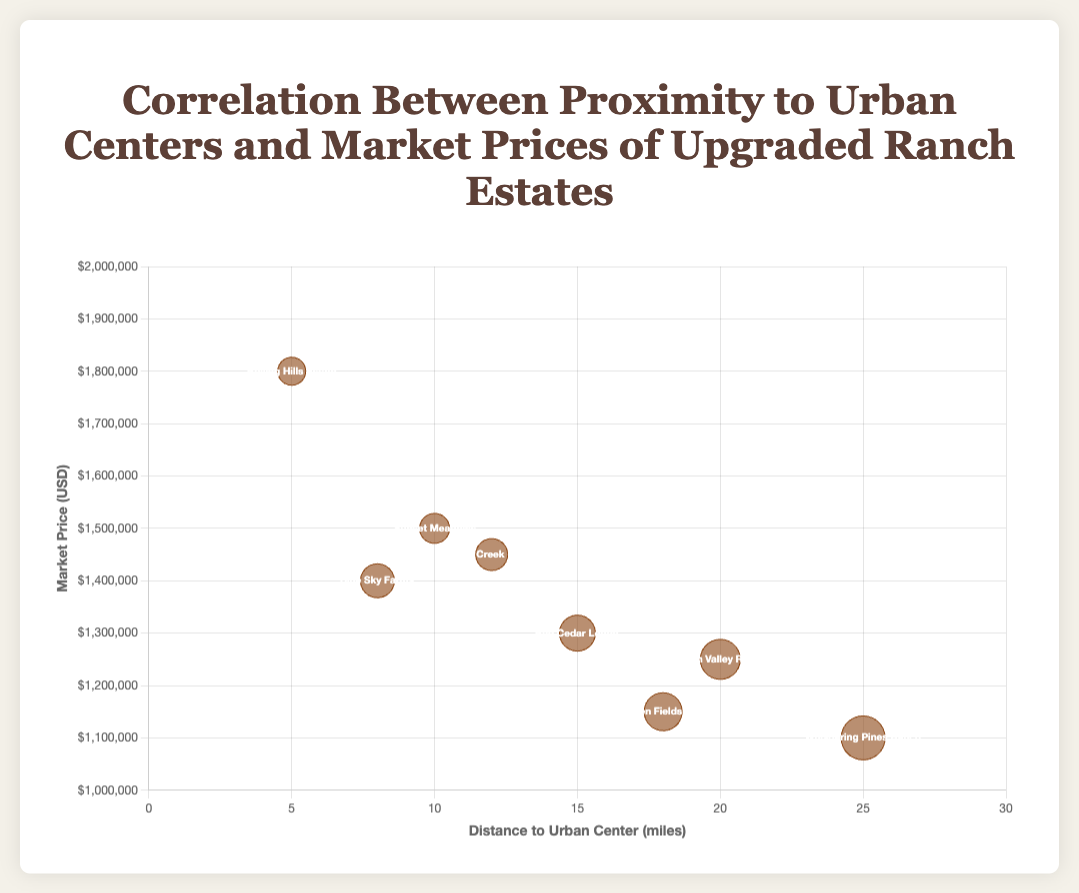What is the property closest to an urban center? By looking at the x-axis values, the property with the smallest distance to the urban center is "Rolling Hills Estate," which is 5 miles away.
Answer: Rolling Hills Estate Which property is the most expensive? By observing the y-values, the highest market price is $1,800,000, attributed to "Rolling Hills Estate."
Answer: Rolling Hills Estate Which property is furthest from an urban center? By looking at the x-axis, the property that is farthest from an urban center is "Whispering Pines Ranch," which is 25 miles away.
Answer: Whispering Pines Ranch How many properties are plotted in the chart? There are 8 data points on the chart, each representing a different ranch estate.
Answer: 8 What is the market price and size of "Green Valley Ranch"? The tooltip shows "Green Valley Ranch" has a market price of $1,250,000 and a size of 120 acres.
Answer: $1,250,000, 120 acres Which property has the largest bubble size, and what might it represent? The largest bubble represents "Whispering Pines Ranch," and the size likely corresponds to having the largest acreage, which is 150 acres.
Answer: Whispering Pines Ranch How does the market price generally change with increasing distance from the urban center? Generally, properties closer to the urban center tend to have higher market prices, while those farther away have lower prices, though there are some exceptions.
Answer: Decreases What is the average market price of properties that are 15 miles or closer to the urban center? Properties within 15 miles are "Sunset Meadows ($1,500,000)", "Rolling Hills Estate ($1,800,000)", "Blue Sky Farms ($1,400,000)", "Red Cedar Lodge ($1,300,000)", and "Silver Creek Ranch ($1,450,000)". Average price is (1500000 + 1800000 + 1400000 + 1300000 + 1450000)/5 = $1,480,000.
Answer: $1,480,000 Which two properties have the same bubble size, and how far apart are they from the urban center? "Sunset Meadows" and "Silver Creek Ranch" both have bubble sizes corresponding to 75 and 80 acres, respectively. They are 10 miles and 12 miles from the urban center.
Answer: Sunset Meadows and Silver Creek Ranch, 2 miles apart 